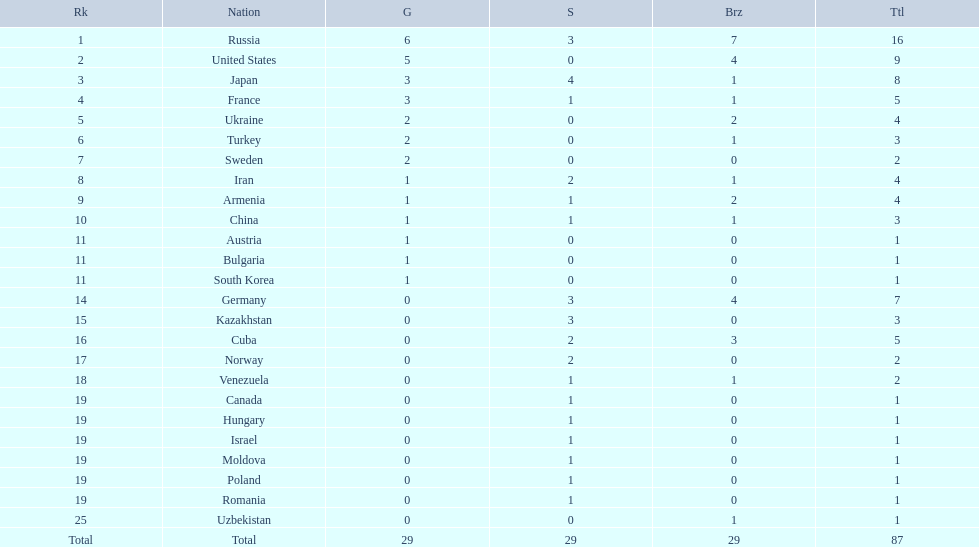Which countries competed in the 1995 world wrestling championships? Russia, United States, Japan, France, Ukraine, Turkey, Sweden, Iran, Armenia, China, Austria, Bulgaria, South Korea, Germany, Kazakhstan, Cuba, Norway, Venezuela, Canada, Hungary, Israel, Moldova, Poland, Romania, Uzbekistan. What country won only one medal? Austria, Bulgaria, South Korea, Canada, Hungary, Israel, Moldova, Poland, Romania, Uzbekistan. Which of these won a bronze medal? Uzbekistan. 